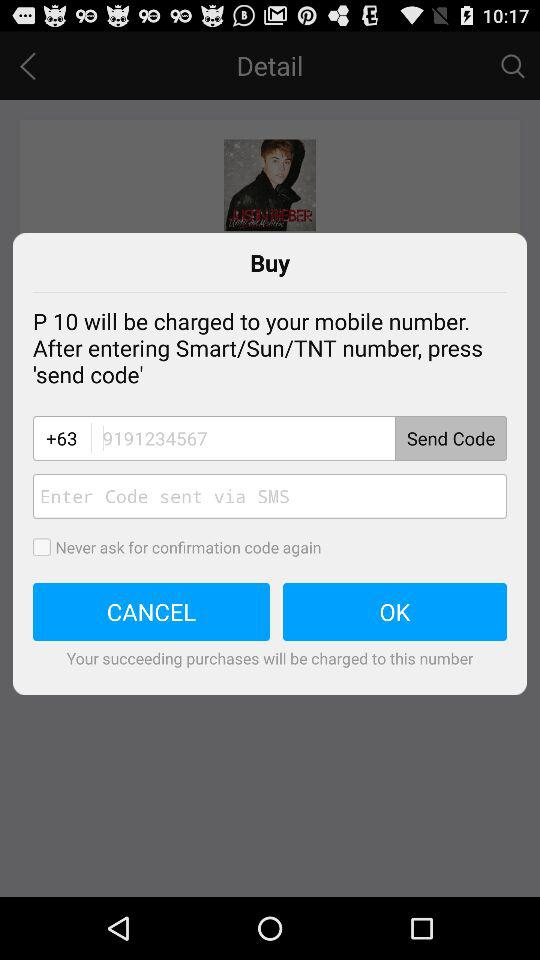What number is shown in the input field? The shown number in the input field is 9191234567. 